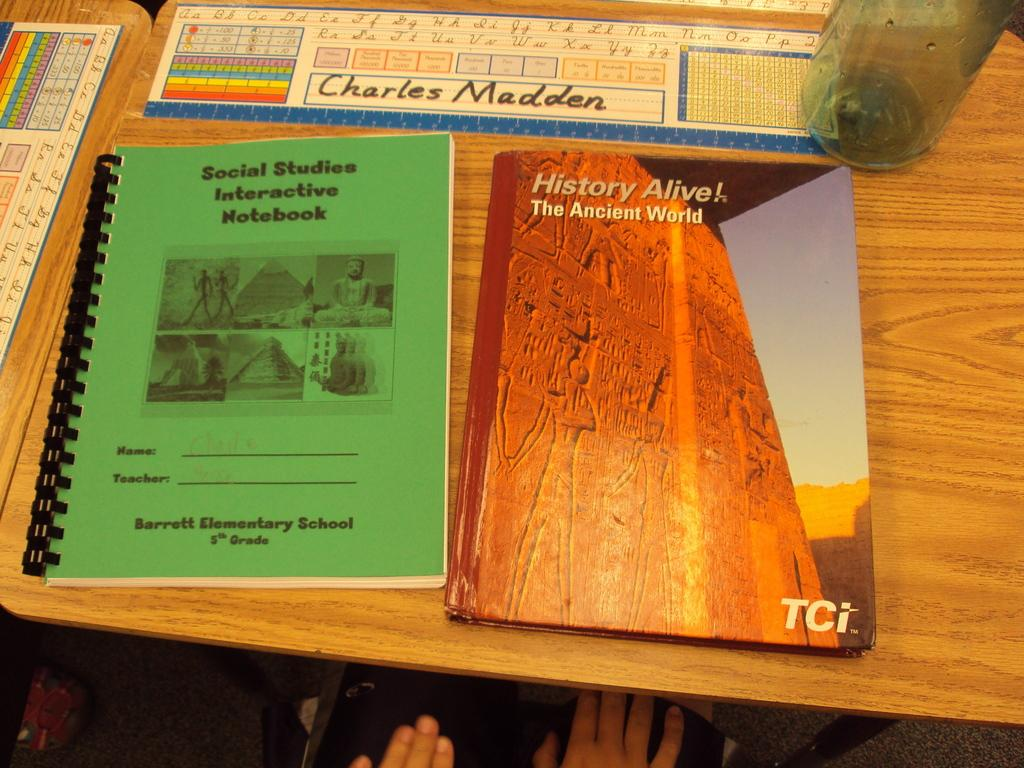<image>
Share a concise interpretation of the image provided. A green workbook, and a text book titled History Alive next to each other on a desk. 